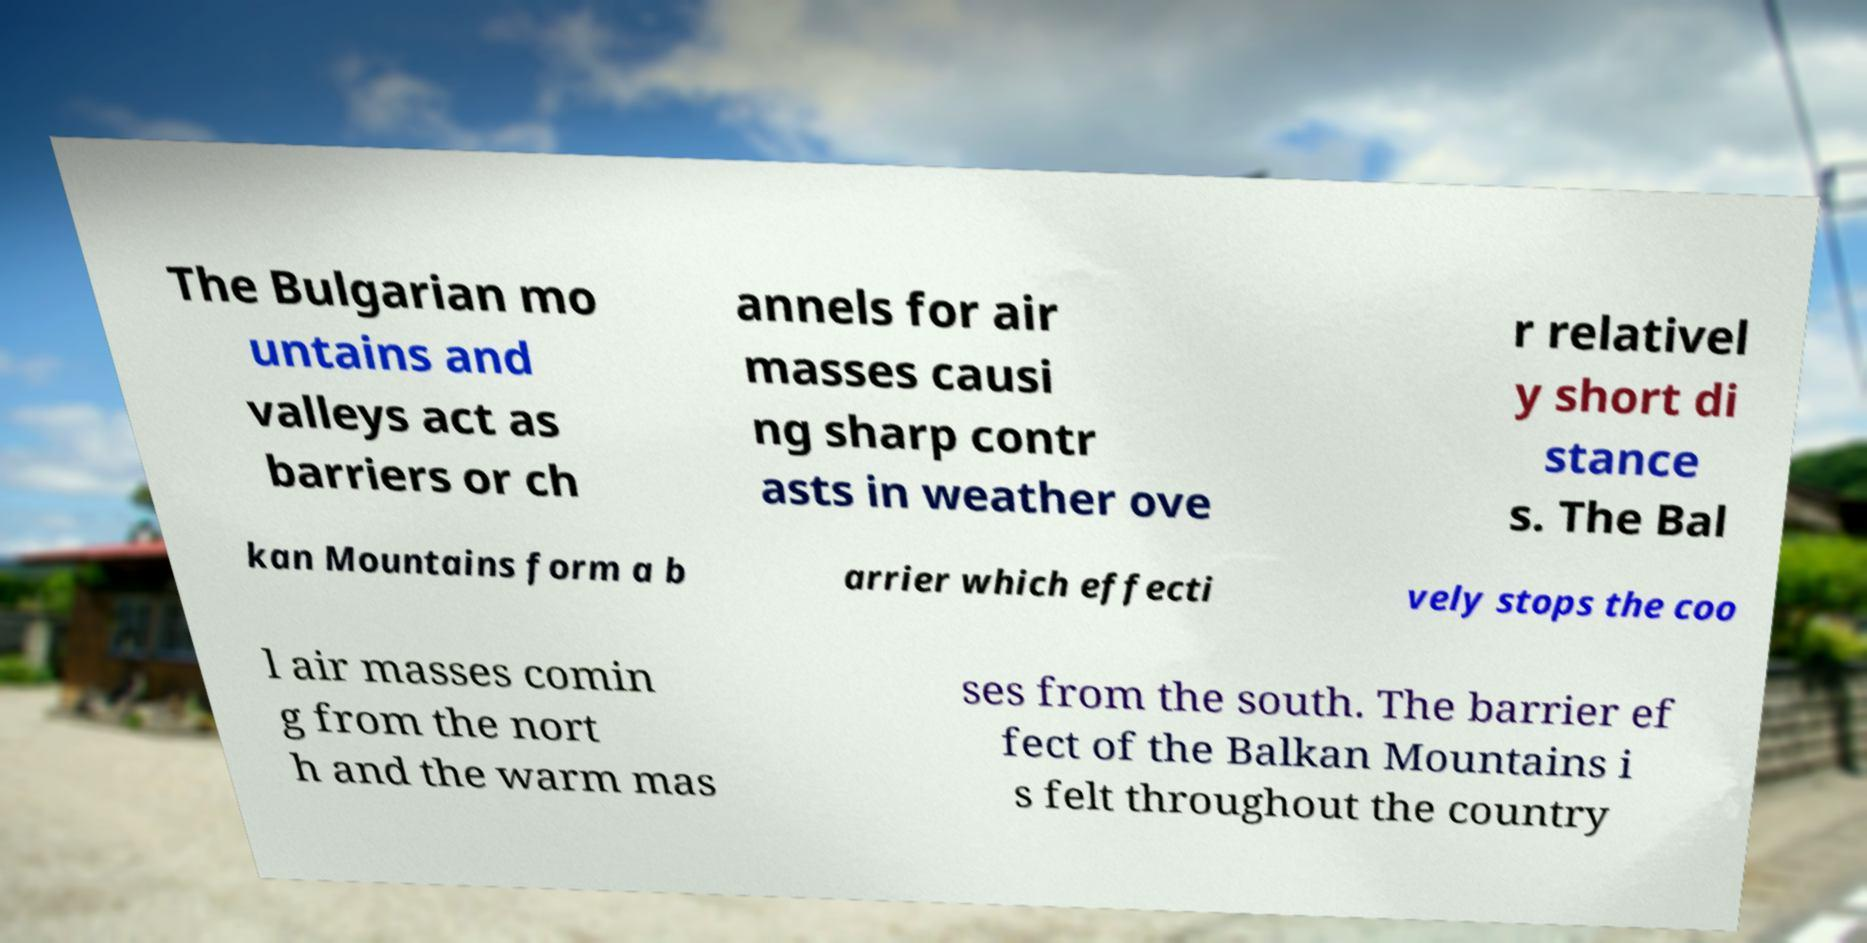Please read and relay the text visible in this image. What does it say? The Bulgarian mo untains and valleys act as barriers or ch annels for air masses causi ng sharp contr asts in weather ove r relativel y short di stance s. The Bal kan Mountains form a b arrier which effecti vely stops the coo l air masses comin g from the nort h and the warm mas ses from the south. The barrier ef fect of the Balkan Mountains i s felt throughout the country 